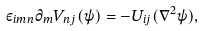<formula> <loc_0><loc_0><loc_500><loc_500>\varepsilon _ { i m n } \partial _ { m } V _ { n j } ( \psi ) = - U _ { i j } ( \nabla ^ { 2 } \psi ) ,</formula> 